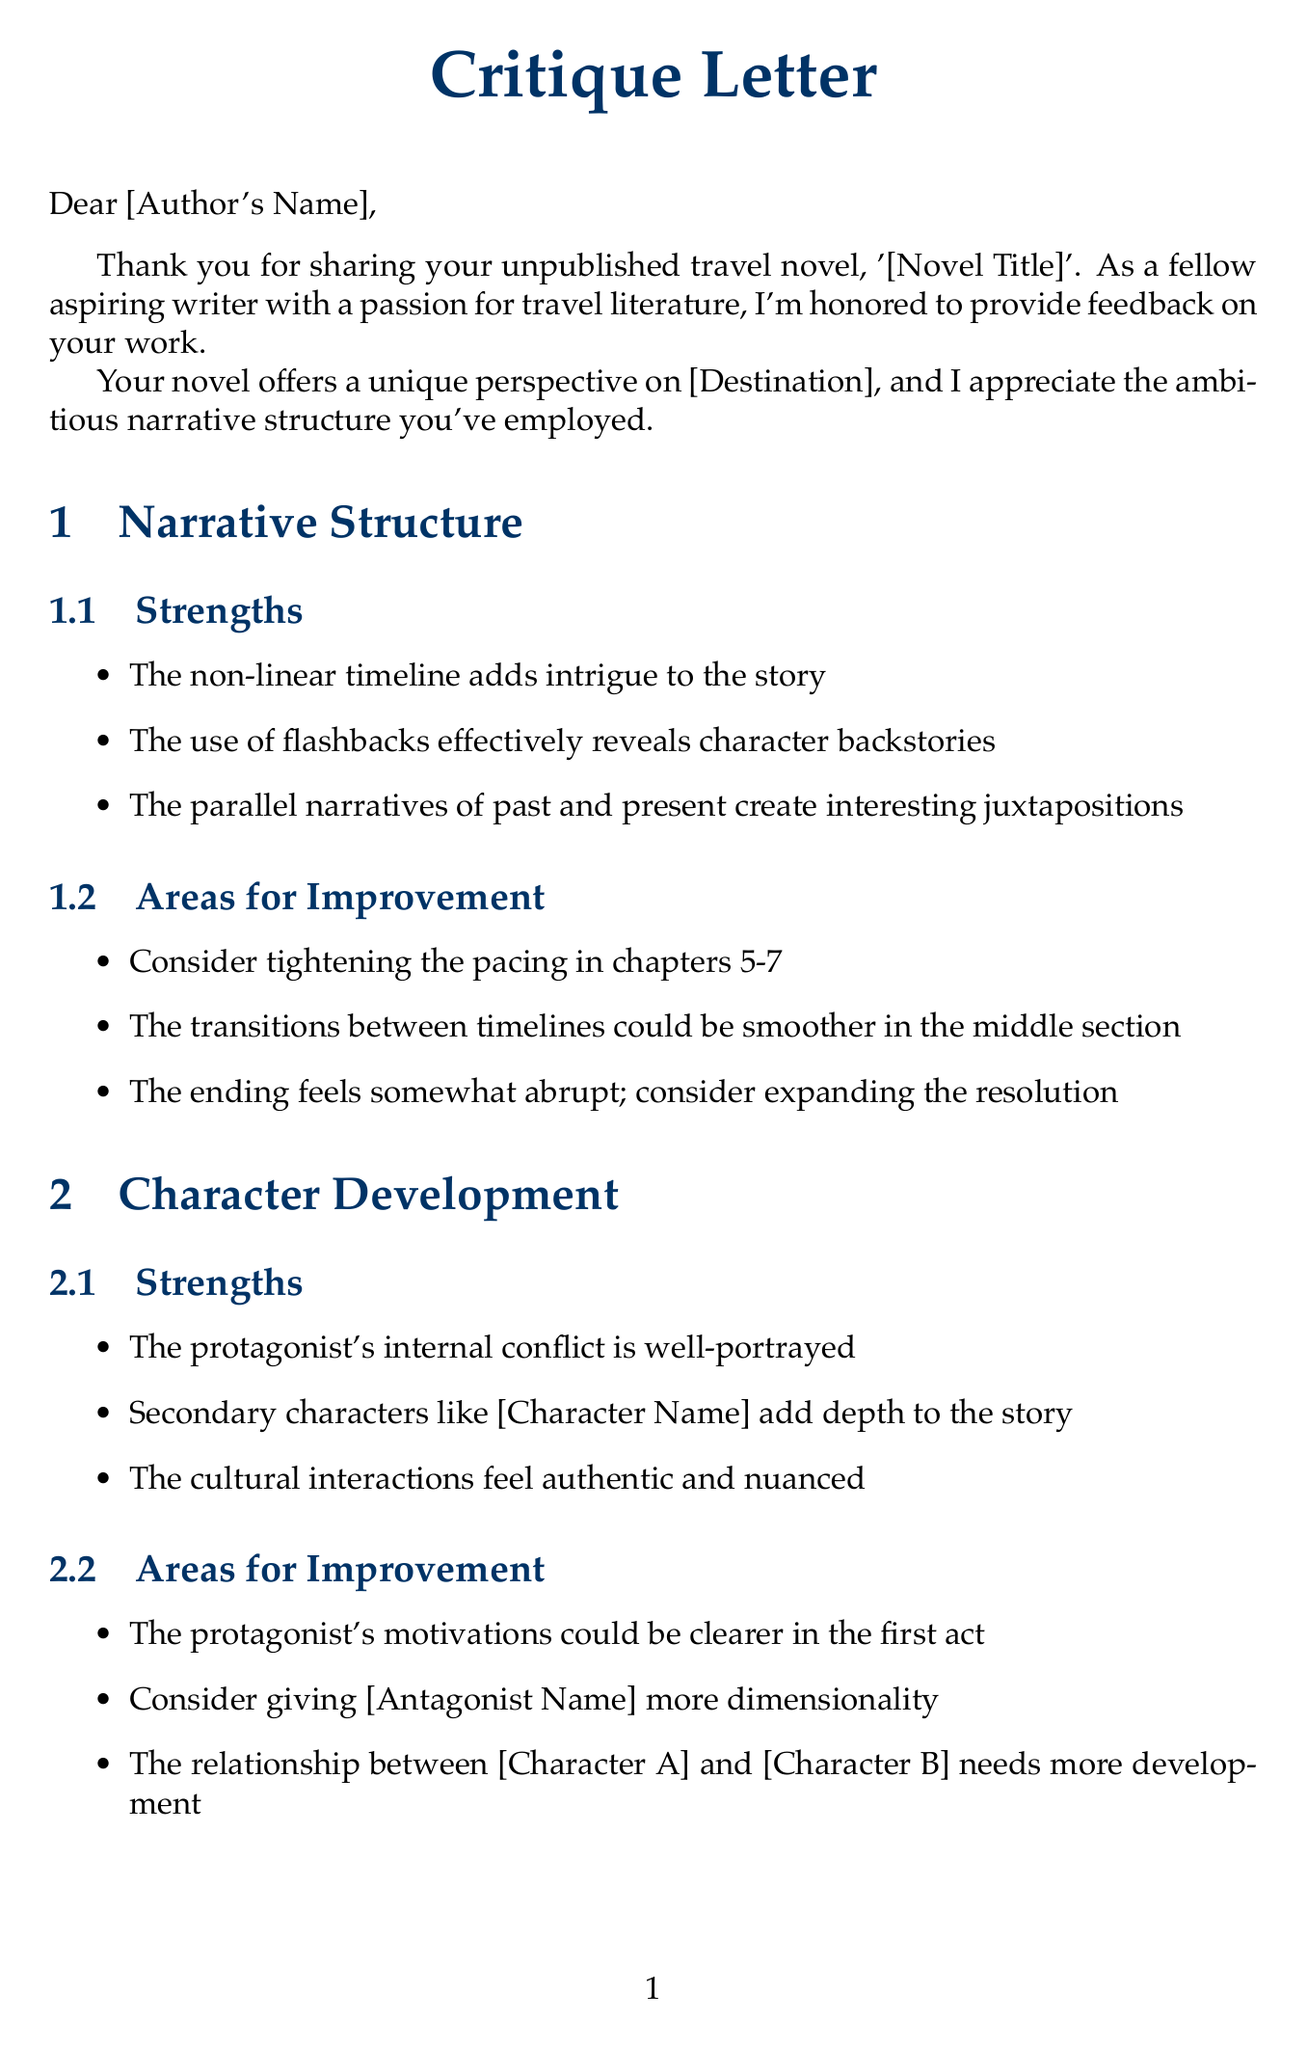What is the title of the novel? The title of the novel is mentioned in the greeting section of the document.
Answer: [Novel Title] Who is the recipient of the letter? The recipient is referred to in the greeting section of the document as the author of the novel.
Answer: [Author's Name] What is one strength of the narrative structure? One strength listed in the document regarding narrative structure is that it adds intrigue to the story.
Answer: The non-linear timeline adds intrigue to the story Which character needs more dimensionality? The document points out that a specific character could be improved in terms of dimensionality.
Answer: [Antagonist Name] What literary technique is suggested for consideration? The document provides recommendations for literary techniques that can enhance the work.
Answer: Use of unreliable narrator Name one publisher mentioned for potential publication. The document lists potential publishers for the novel.
Answer: Lonely Planet How does the letter conclude? The conclusion summarizes the author's feedback and offers encouragement.
Answer: Your novel shows great promise What does the author recommend reading for character development inspiration? A specific book is suggested to the author for improving character development.
Answer: What I Was Doing While You Were Breeding What is a noted area for improvement in setting descriptions? A specific critique regarding the description in the document points to areas needing improvement.
Answer: Some descriptions of [Landmark] feel overwrought 